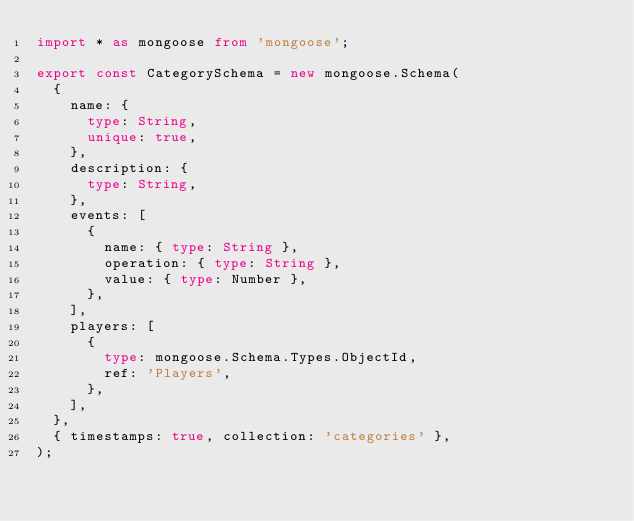Convert code to text. <code><loc_0><loc_0><loc_500><loc_500><_TypeScript_>import * as mongoose from 'mongoose';

export const CategorySchema = new mongoose.Schema(
  {
    name: {
      type: String,
      unique: true,
    },
    description: {
      type: String,
    },
    events: [
      {
        name: { type: String },
        operation: { type: String },
        value: { type: Number },
      },
    ],
    players: [
      {
        type: mongoose.Schema.Types.ObjectId,
        ref: 'Players',
      },
    ],
  },
  { timestamps: true, collection: 'categories' },
);
</code> 